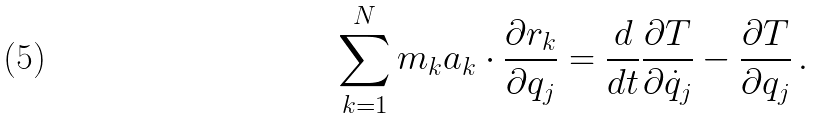Convert formula to latex. <formula><loc_0><loc_0><loc_500><loc_500>\sum _ { k = 1 } ^ { N } m _ { k } a _ { k } \cdot { \frac { \partial r _ { k } } { \partial q _ { j } } } = { \frac { d } { d t } } { \frac { \partial T } { \partial { \dot { q } } _ { j } } } - { \frac { \partial T } { \partial q _ { j } } } \, .</formula> 